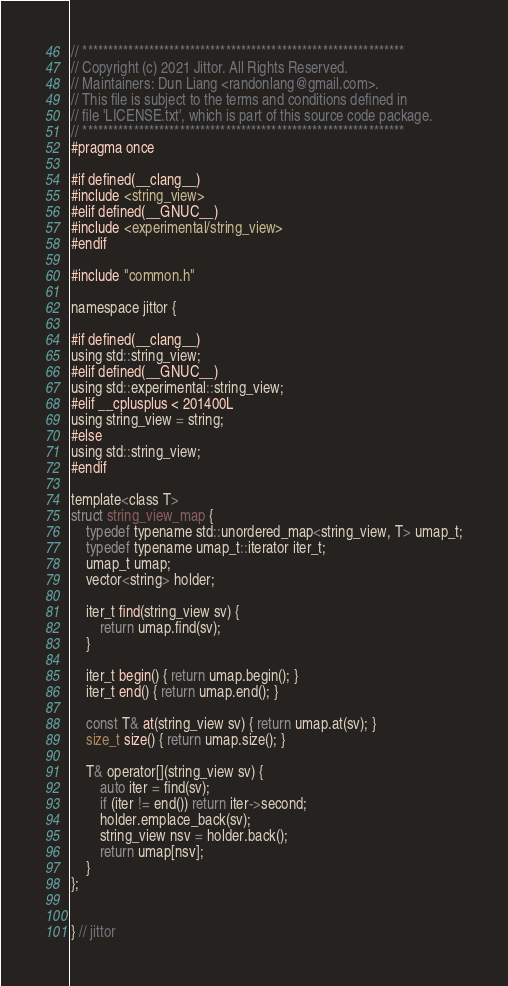Convert code to text. <code><loc_0><loc_0><loc_500><loc_500><_C_>// ***************************************************************
// Copyright (c) 2021 Jittor. All Rights Reserved. 
// Maintainers: Dun Liang <randonlang@gmail.com>. 
// This file is subject to the terms and conditions defined in
// file 'LICENSE.txt', which is part of this source code package.
// ***************************************************************
#pragma once

#if defined(__clang__)
#include <string_view>
#elif defined(__GNUC__)
#include <experimental/string_view>
#endif

#include "common.h"

namespace jittor {

#if defined(__clang__)
using std::string_view;
#elif defined(__GNUC__)
using std::experimental::string_view;
#elif __cplusplus < 201400L
using string_view = string;
#else
using std::string_view;
#endif

template<class T>
struct string_view_map {
    typedef typename std::unordered_map<string_view, T> umap_t;
    typedef typename umap_t::iterator iter_t;
    umap_t umap;
    vector<string> holder;

    iter_t find(string_view sv) {
        return umap.find(sv);
    }

    iter_t begin() { return umap.begin(); }
    iter_t end() { return umap.end(); }

    const T& at(string_view sv) { return umap.at(sv); }
    size_t size() { return umap.size(); }

    T& operator[](string_view sv) {
        auto iter = find(sv);
        if (iter != end()) return iter->second;
        holder.emplace_back(sv);
        string_view nsv = holder.back();
        return umap[nsv];
    }
};


} // jittor
</code> 